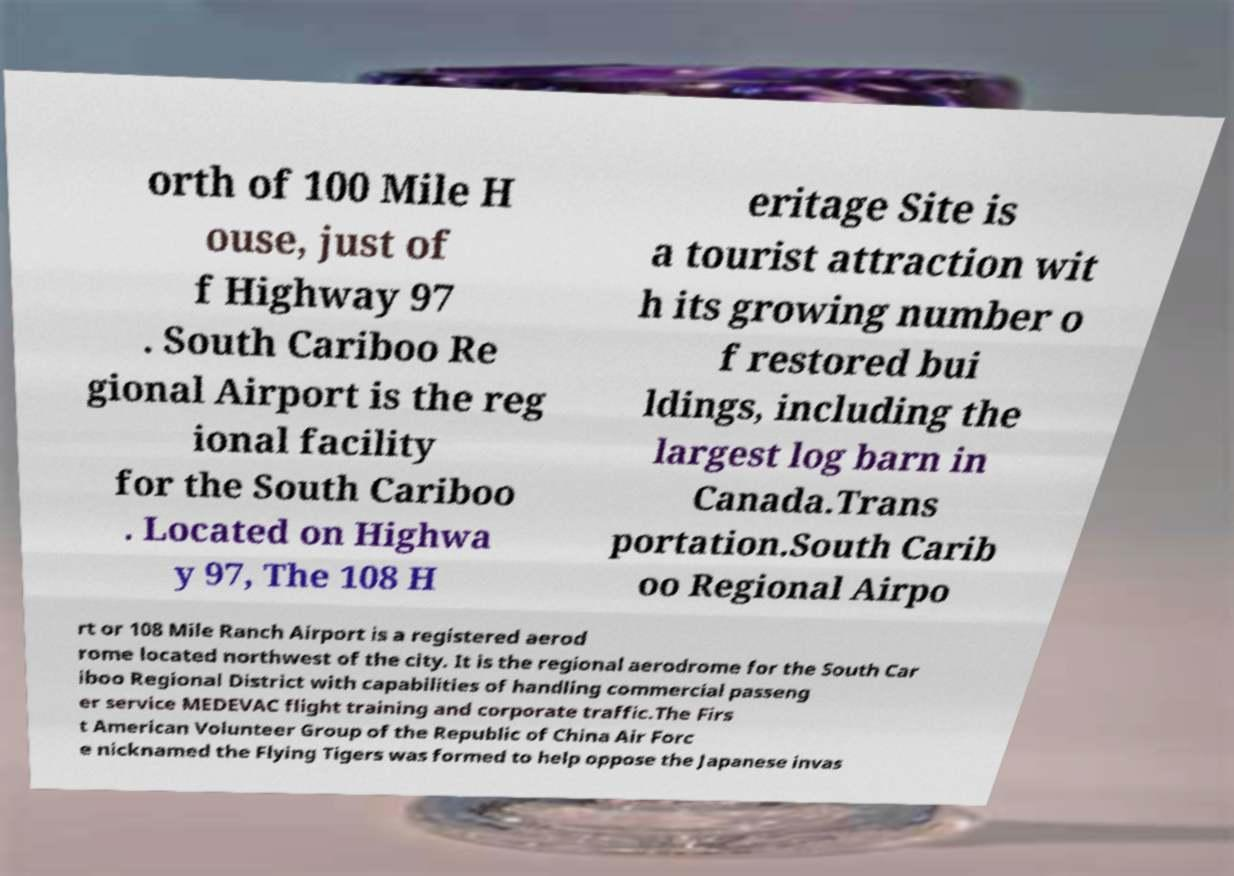Could you assist in decoding the text presented in this image and type it out clearly? orth of 100 Mile H ouse, just of f Highway 97 . South Cariboo Re gional Airport is the reg ional facility for the South Cariboo . Located on Highwa y 97, The 108 H eritage Site is a tourist attraction wit h its growing number o f restored bui ldings, including the largest log barn in Canada.Trans portation.South Carib oo Regional Airpo rt or 108 Mile Ranch Airport is a registered aerod rome located northwest of the city. It is the regional aerodrome for the South Car iboo Regional District with capabilities of handling commercial passeng er service MEDEVAC flight training and corporate traffic.The Firs t American Volunteer Group of the Republic of China Air Forc e nicknamed the Flying Tigers was formed to help oppose the Japanese invas 